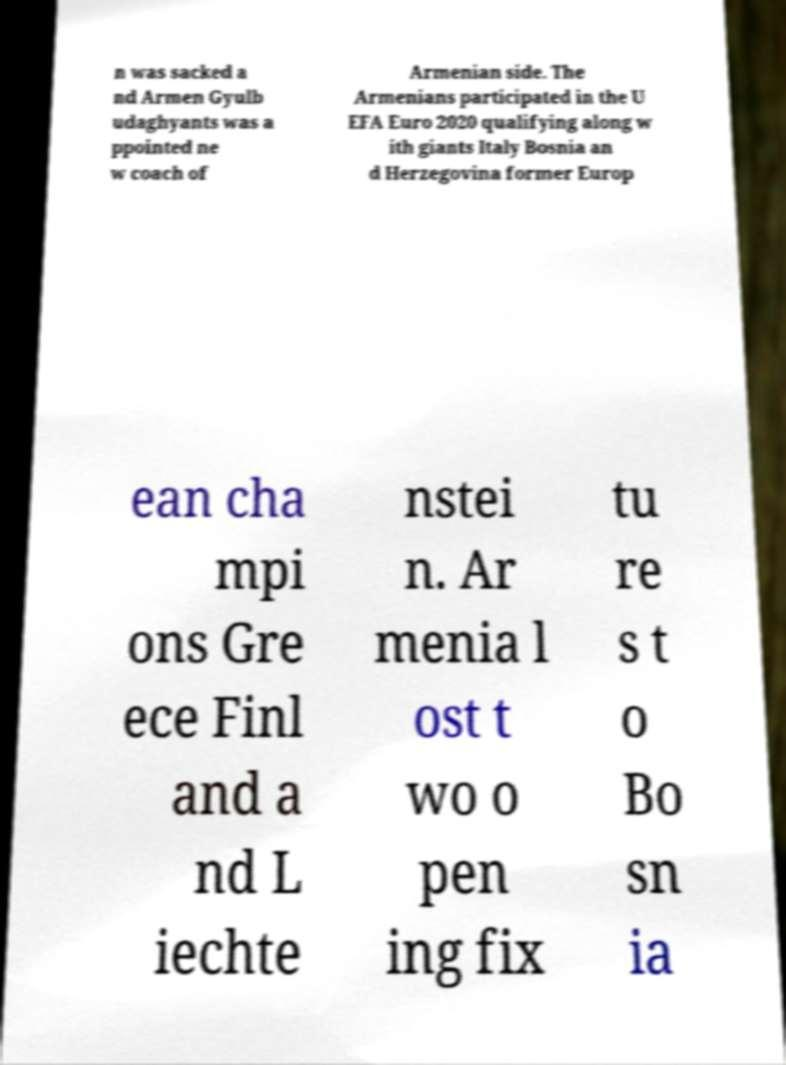Could you extract and type out the text from this image? n was sacked a nd Armen Gyulb udaghyants was a ppointed ne w coach of Armenian side. The Armenians participated in the U EFA Euro 2020 qualifying along w ith giants Italy Bosnia an d Herzegovina former Europ ean cha mpi ons Gre ece Finl and a nd L iechte nstei n. Ar menia l ost t wo o pen ing fix tu re s t o Bo sn ia 